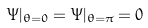Convert formula to latex. <formula><loc_0><loc_0><loc_500><loc_500>\Psi | _ { \theta = 0 } = \Psi | _ { \theta = \pi } = 0</formula> 